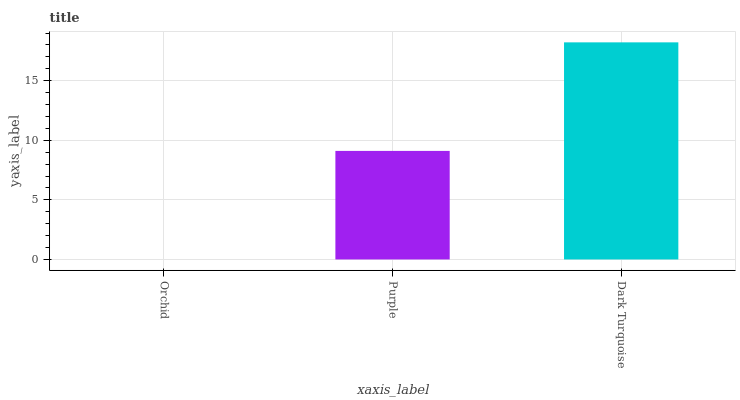Is Orchid the minimum?
Answer yes or no. Yes. Is Dark Turquoise the maximum?
Answer yes or no. Yes. Is Purple the minimum?
Answer yes or no. No. Is Purple the maximum?
Answer yes or no. No. Is Purple greater than Orchid?
Answer yes or no. Yes. Is Orchid less than Purple?
Answer yes or no. Yes. Is Orchid greater than Purple?
Answer yes or no. No. Is Purple less than Orchid?
Answer yes or no. No. Is Purple the high median?
Answer yes or no. Yes. Is Purple the low median?
Answer yes or no. Yes. Is Orchid the high median?
Answer yes or no. No. Is Dark Turquoise the low median?
Answer yes or no. No. 